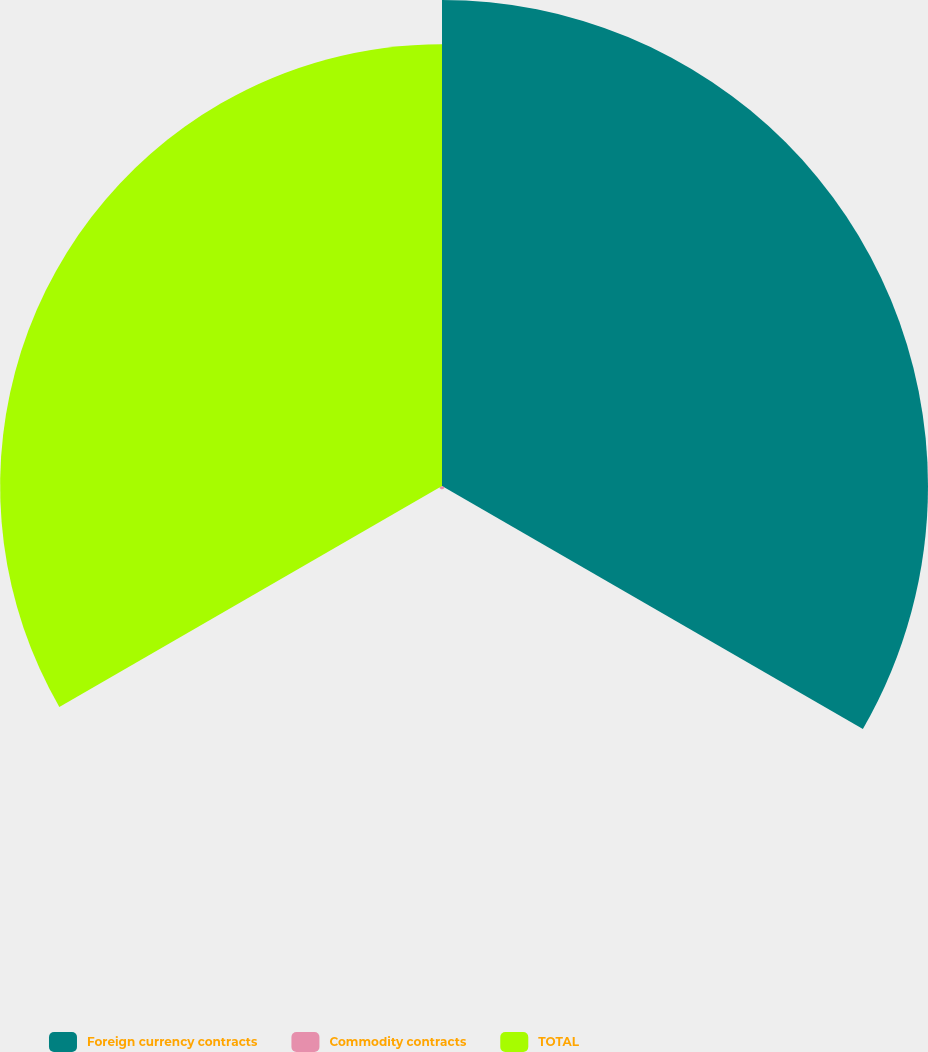Convert chart. <chart><loc_0><loc_0><loc_500><loc_500><pie_chart><fcel>Foreign currency contracts<fcel>Commodity contracts<fcel>TOTAL<nl><fcel>52.2%<fcel>0.34%<fcel>47.46%<nl></chart> 